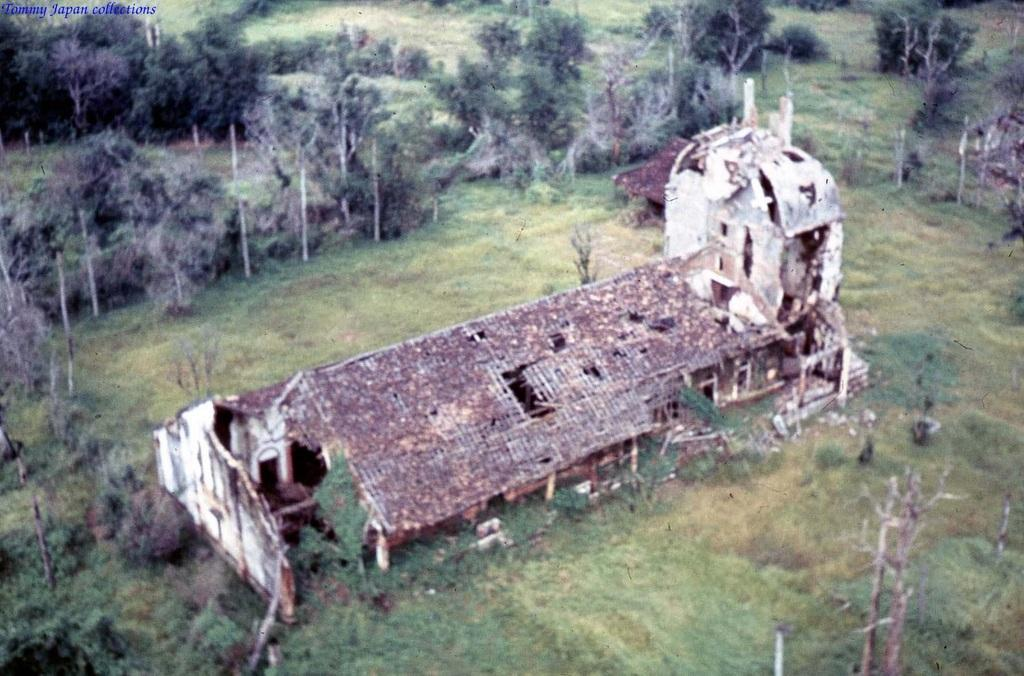What type of structure is visible in the image? There is a building in the image. What is the ground covered with in the image? There is grass on the ground in the image. Are there any plants visible in the image? Yes, there are trees in the image. How many boats can be seen in the image? There are no boats present in the image. What type of net is used to catch the birds in the image? There are no birds or nets present in the image. 